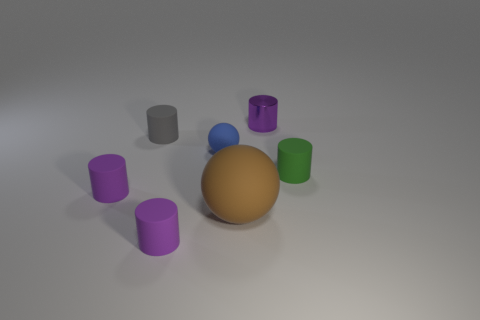Subtract all purple cylinders. How many were subtracted if there are1purple cylinders left? 2 Add 1 green shiny cubes. How many objects exist? 8 Subtract all tiny gray cylinders. How many cylinders are left? 4 Subtract all green cylinders. How many cylinders are left? 4 Add 7 brown matte balls. How many brown matte balls are left? 8 Add 3 matte objects. How many matte objects exist? 9 Subtract 3 purple cylinders. How many objects are left? 4 Subtract all cylinders. How many objects are left? 2 Subtract all brown cylinders. Subtract all gray balls. How many cylinders are left? 5 Subtract all red cylinders. How many purple spheres are left? 0 